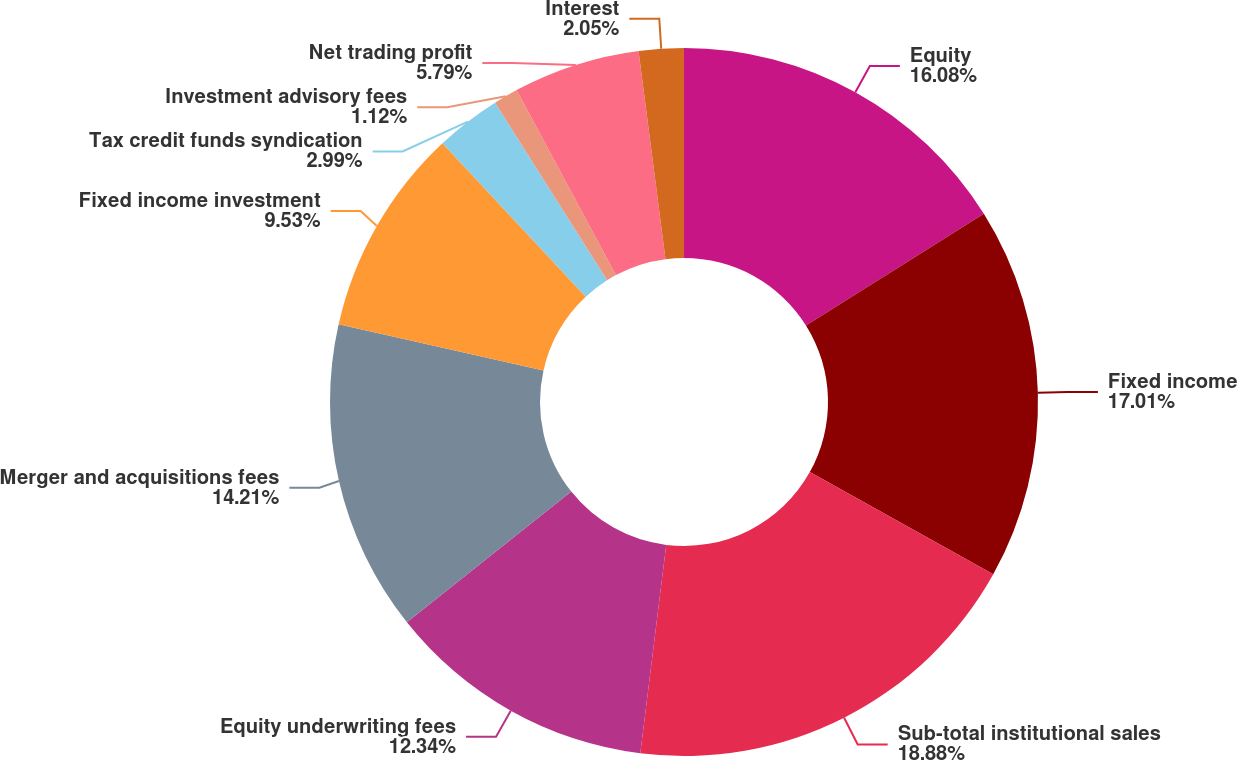Convert chart to OTSL. <chart><loc_0><loc_0><loc_500><loc_500><pie_chart><fcel>Equity<fcel>Fixed income<fcel>Sub-total institutional sales<fcel>Equity underwriting fees<fcel>Merger and acquisitions fees<fcel>Fixed income investment<fcel>Tax credit funds syndication<fcel>Investment advisory fees<fcel>Net trading profit<fcel>Interest<nl><fcel>16.08%<fcel>17.01%<fcel>18.88%<fcel>12.34%<fcel>14.21%<fcel>9.53%<fcel>2.99%<fcel>1.12%<fcel>5.79%<fcel>2.05%<nl></chart> 